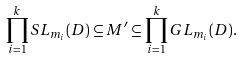<formula> <loc_0><loc_0><loc_500><loc_500>\prod _ { i = 1 } ^ { k } S L _ { m _ { i } } ( D ) \subseteq M ^ { \prime } \subseteq \prod _ { i = 1 } ^ { k } G L _ { m _ { i } } ( D ) .</formula> 